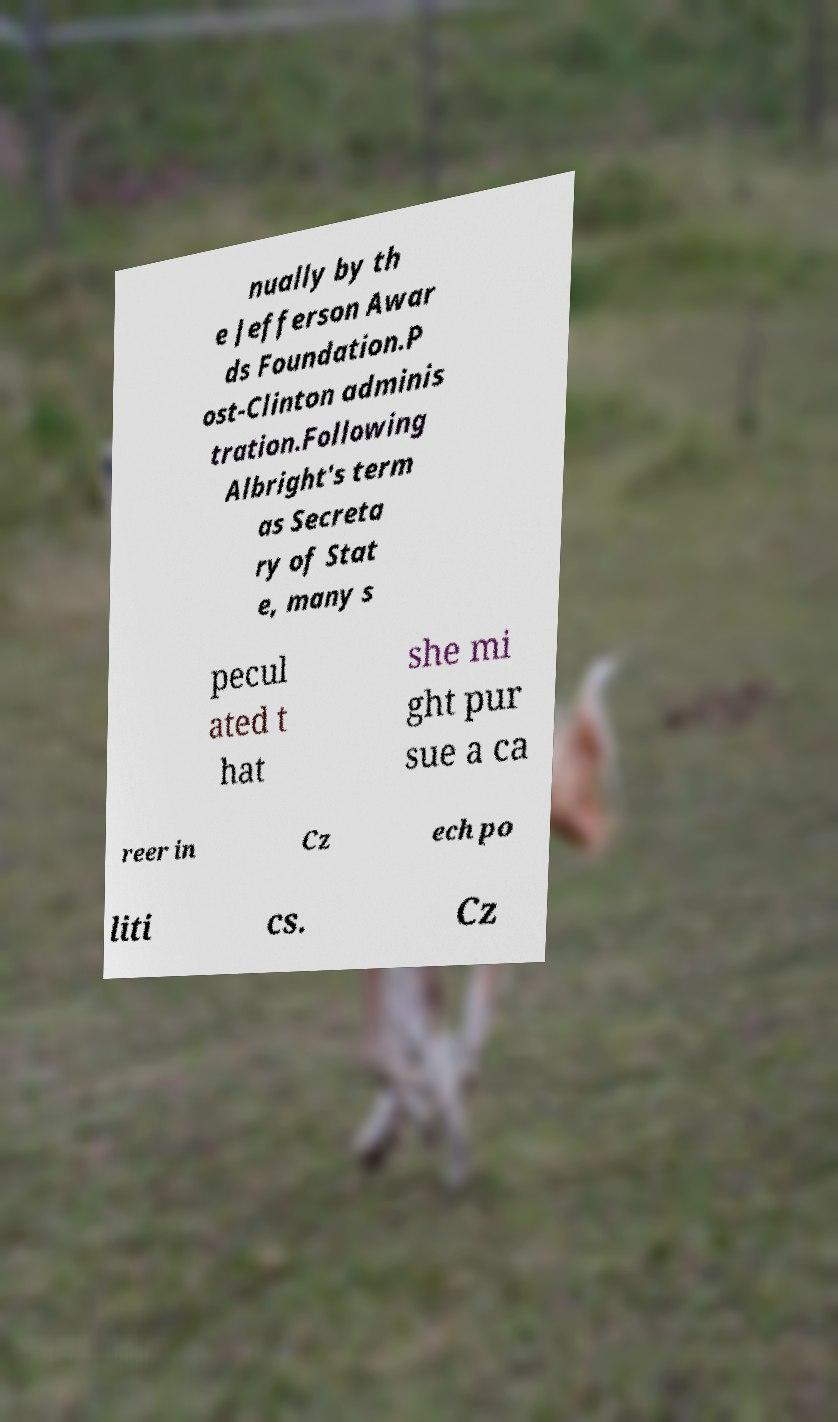Could you extract and type out the text from this image? nually by th e Jefferson Awar ds Foundation.P ost-Clinton adminis tration.Following Albright's term as Secreta ry of Stat e, many s pecul ated t hat she mi ght pur sue a ca reer in Cz ech po liti cs. Cz 